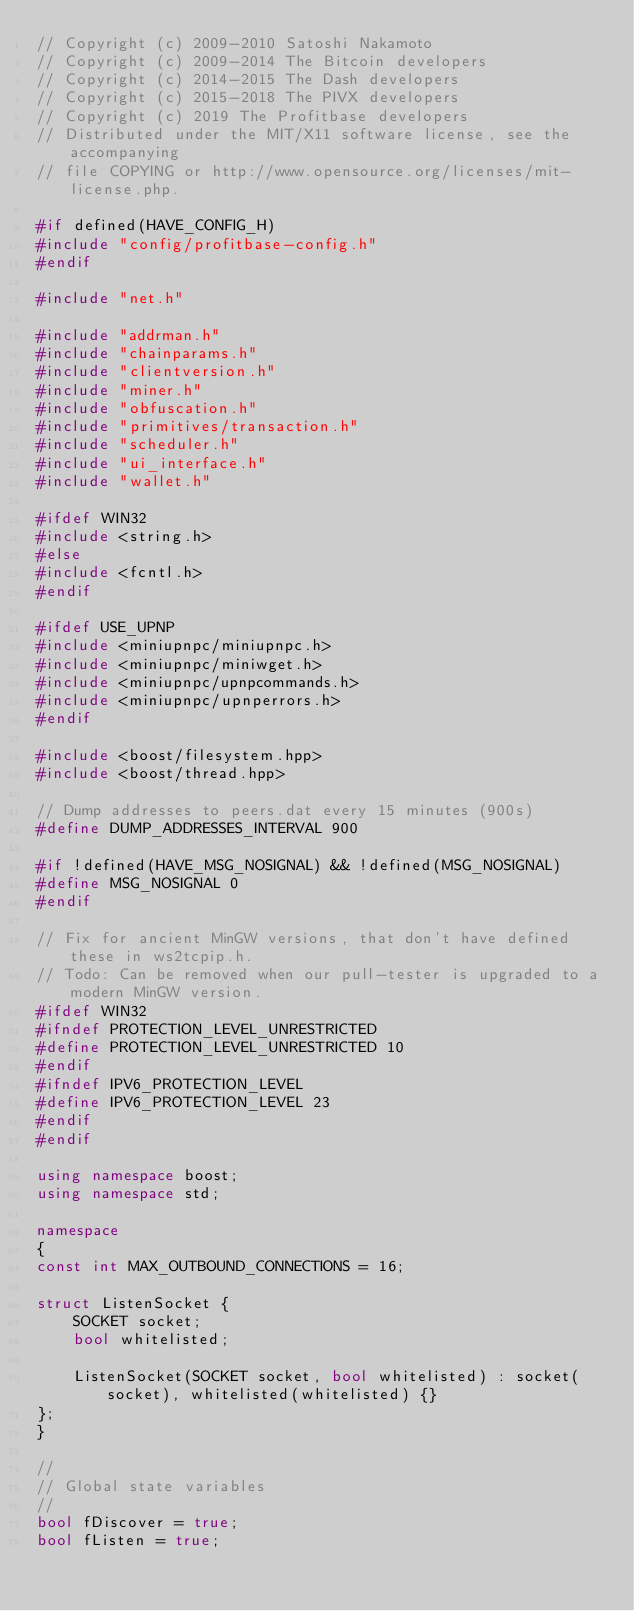Convert code to text. <code><loc_0><loc_0><loc_500><loc_500><_C++_>// Copyright (c) 2009-2010 Satoshi Nakamoto
// Copyright (c) 2009-2014 The Bitcoin developers
// Copyright (c) 2014-2015 The Dash developers
// Copyright (c) 2015-2018 The PIVX developers
// Copyright (c) 2019 The Profitbase developers
// Distributed under the MIT/X11 software license, see the accompanying
// file COPYING or http://www.opensource.org/licenses/mit-license.php.

#if defined(HAVE_CONFIG_H)
#include "config/profitbase-config.h"
#endif

#include "net.h"

#include "addrman.h"
#include "chainparams.h"
#include "clientversion.h"
#include "miner.h"
#include "obfuscation.h"
#include "primitives/transaction.h"
#include "scheduler.h"
#include "ui_interface.h"
#include "wallet.h"

#ifdef WIN32
#include <string.h>
#else
#include <fcntl.h>
#endif

#ifdef USE_UPNP
#include <miniupnpc/miniupnpc.h>
#include <miniupnpc/miniwget.h>
#include <miniupnpc/upnpcommands.h>
#include <miniupnpc/upnperrors.h>
#endif

#include <boost/filesystem.hpp>
#include <boost/thread.hpp>

// Dump addresses to peers.dat every 15 minutes (900s)
#define DUMP_ADDRESSES_INTERVAL 900

#if !defined(HAVE_MSG_NOSIGNAL) && !defined(MSG_NOSIGNAL)
#define MSG_NOSIGNAL 0
#endif

// Fix for ancient MinGW versions, that don't have defined these in ws2tcpip.h.
// Todo: Can be removed when our pull-tester is upgraded to a modern MinGW version.
#ifdef WIN32
#ifndef PROTECTION_LEVEL_UNRESTRICTED
#define PROTECTION_LEVEL_UNRESTRICTED 10
#endif
#ifndef IPV6_PROTECTION_LEVEL
#define IPV6_PROTECTION_LEVEL 23
#endif
#endif

using namespace boost;
using namespace std;

namespace
{
const int MAX_OUTBOUND_CONNECTIONS = 16;

struct ListenSocket {
    SOCKET socket;
    bool whitelisted;

    ListenSocket(SOCKET socket, bool whitelisted) : socket(socket), whitelisted(whitelisted) {}
};
}

//
// Global state variables
//
bool fDiscover = true;
bool fListen = true;</code> 